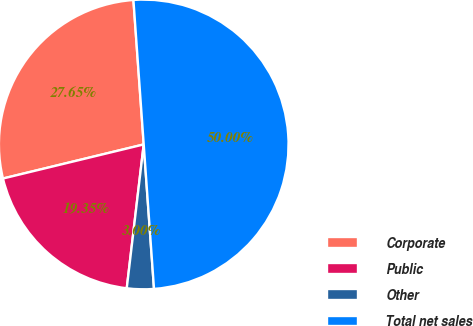Convert chart. <chart><loc_0><loc_0><loc_500><loc_500><pie_chart><fcel>Corporate<fcel>Public<fcel>Other<fcel>Total net sales<nl><fcel>27.65%<fcel>19.35%<fcel>3.0%<fcel>50.0%<nl></chart> 